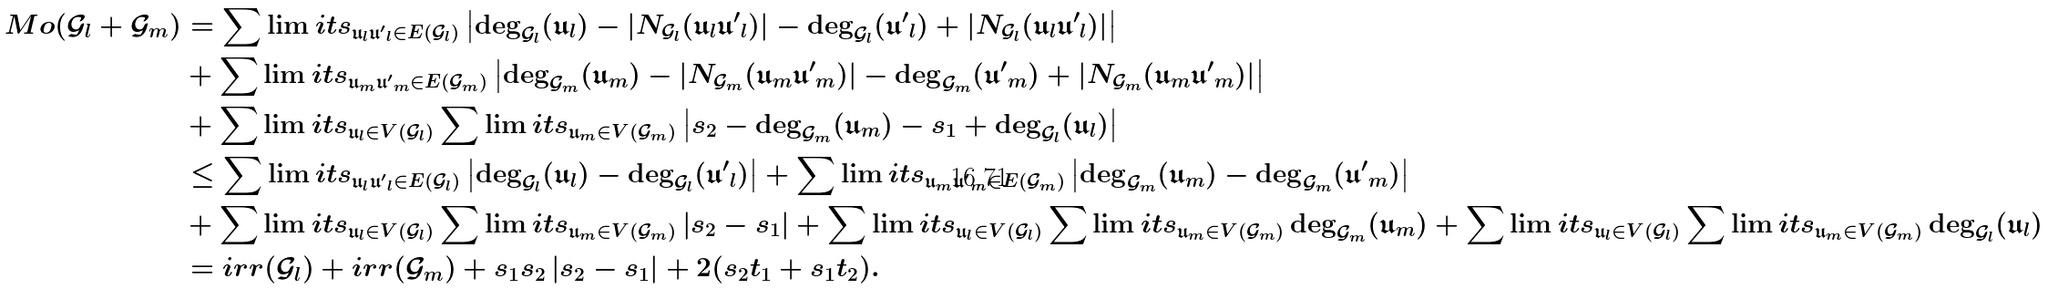Convert formula to latex. <formula><loc_0><loc_0><loc_500><loc_500>M o ( \mathcal { G } _ { l } + \mathcal { G } _ { m } ) & = \sum \lim i t s _ { \mathfrak { u } _ { l } \mathfrak { u ^ { \prime } } _ { l } \in E ( \mathcal { G } _ { l } ) } \left | \deg _ { \mathcal { G } _ { l } } ( \mathfrak { u } _ { l } ) - | N _ { \mathcal { G } _ { l } } ( \mathfrak { u } _ { l } \mathfrak { u ^ { \prime } } _ { l } ) | - \deg _ { \mathcal { G } _ { l } } ( \mathfrak { u ^ { \prime } } _ { l } ) + | N _ { \mathcal { G } _ { l } } ( \mathfrak { u } _ { l } \mathfrak { u ^ { \prime } } _ { l } ) | \right | \\ & + \sum \lim i t s _ { \mathfrak { u } _ { m } \mathfrak { u ^ { \prime } } _ { m } \in E ( \mathcal { G } _ { m } ) } \left | \deg _ { \mathcal { G } _ { m } } ( \mathfrak { u } _ { m } ) - | N _ { \mathcal { G } _ { m } } ( \mathfrak { u } _ { m } \mathfrak { u ^ { \prime } } _ { m } ) | - \deg _ { \mathcal { G } _ { m } } ( \mathfrak { u ^ { \prime } } _ { m } ) + | N _ { \mathcal { G } _ { m } } ( \mathfrak { u } _ { m } \mathfrak { u ^ { \prime } } _ { m } ) | \right | \\ & + \sum \lim i t s _ { \mathfrak { u } _ { l } \in V ( \mathcal { G } _ { l } ) } \sum \lim i t s _ { \mathfrak { u } _ { m } \in V ( \mathcal { G } _ { m } ) } \left | s _ { 2 } - \deg _ { \mathcal { G } _ { m } } ( \mathfrak { u } _ { m } ) - s _ { 1 } + \deg _ { \mathcal { G } _ { l } } ( \mathfrak { u } _ { l } ) \right | \\ & \leq \sum \lim i t s _ { \mathfrak { u } _ { l } \mathfrak { u ^ { \prime } } _ { l } \in E ( \mathcal { G } _ { l } ) } \left | \deg _ { \mathcal { G } _ { l } } ( \mathfrak { u } _ { l } ) - \deg _ { \mathcal { G } _ { l } } ( \mathfrak { u ^ { \prime } } _ { l } ) \right | + \sum \lim i t s _ { \mathfrak { u } _ { m } \mathfrak { u ^ { \prime } } _ { m } \in E ( \mathcal { G } _ { m } ) } \left | \deg _ { \mathcal { G } _ { m } } ( \mathfrak { u } _ { m } ) - \deg _ { \mathcal { G } _ { m } } ( \mathfrak { u ^ { \prime } } _ { m } ) \right | \\ & + \sum \lim i t s _ { \mathfrak { u } _ { l } \in V ( \mathcal { G } _ { l } ) } \sum \lim i t s _ { \mathfrak { u } _ { m } \in V ( \mathcal { G } _ { m } ) } \left | s _ { 2 } - s _ { 1 } \right | + \sum \lim i t s _ { \mathfrak { u } _ { l } \in V ( \mathcal { G } _ { l } ) } \sum \lim i t s _ { \mathfrak { u } _ { m } \in V ( \mathcal { G } _ { m } ) } \deg _ { \mathcal { G } _ { m } } ( \mathfrak { u } _ { m } ) + \sum \lim i t s _ { \mathfrak { u } _ { l } \in V ( \mathcal { G } _ { l } ) } \sum \lim i t s _ { \mathfrak { u } _ { m } \in V ( \mathcal { G } _ { m } ) } \deg _ { \mathcal { G } _ { l } } ( \mathfrak { u } _ { l } ) \\ & = i r r ( \mathcal { G } _ { l } ) + i r r ( \mathcal { G } _ { m } ) + s _ { 1 } s _ { 2 } \left | s _ { 2 } - s _ { 1 } \right | + 2 ( s _ { 2 } t _ { 1 } + s _ { 1 } t _ { 2 } ) .</formula> 